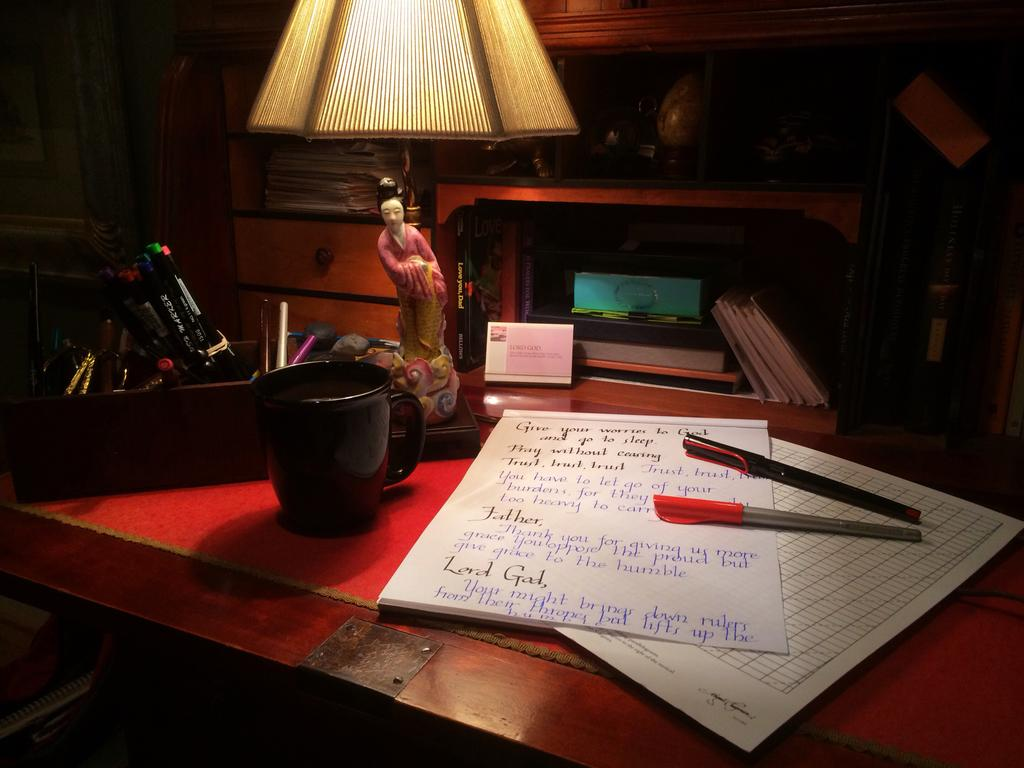What type of table is in the image? There is a wooden table in the image. What items can be seen on the table? Papers, pens, a cup, books, and a table lamp are on the table. What might be used for writing in the image? Pens are on the table, which might be used for writing. What type of lighting is present on the table? There is a table lamp on the table, which provides lighting. What is the quiet plot of the books in the image? There is no plot mentioned in the image, as it only shows a wooden table with various items on it. Additionally, the term "quiet plot" is not applicable in this context. 